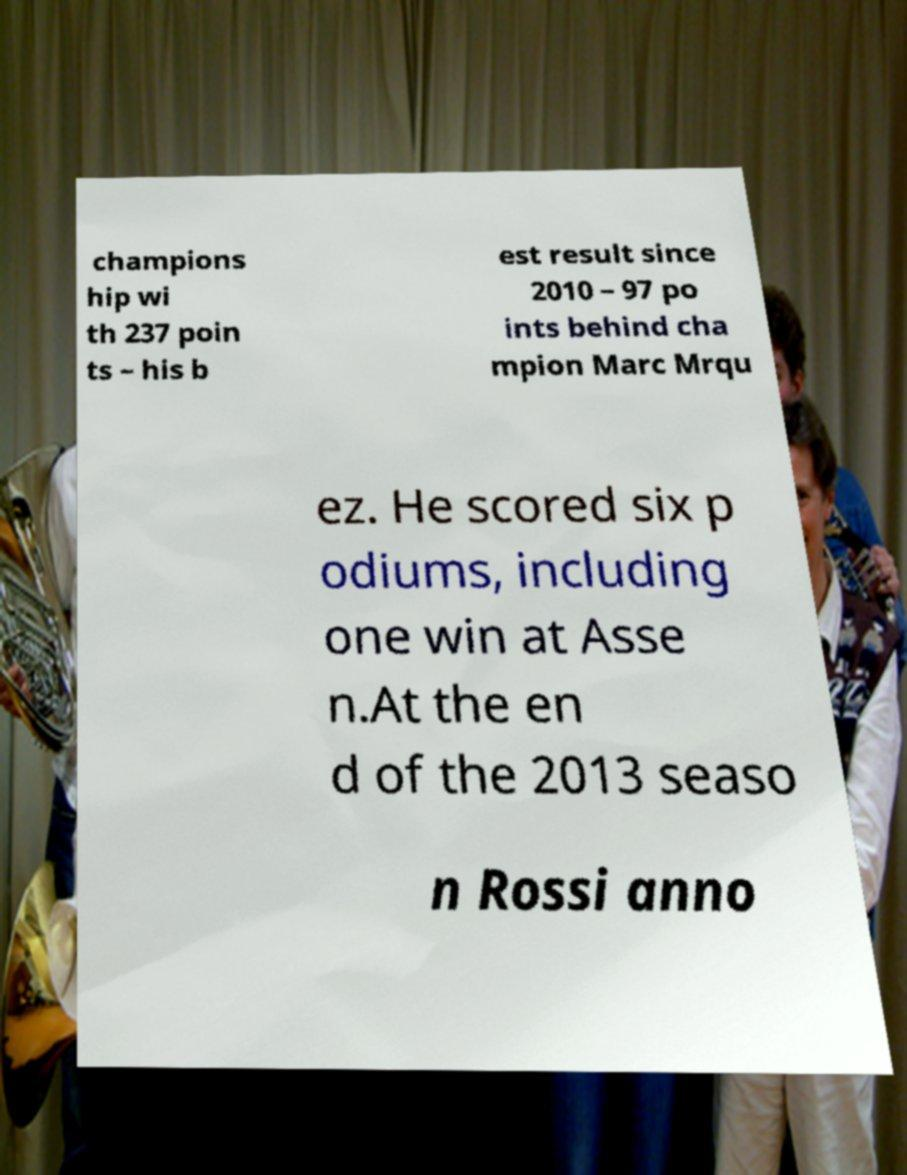There's text embedded in this image that I need extracted. Can you transcribe it verbatim? champions hip wi th 237 poin ts – his b est result since 2010 – 97 po ints behind cha mpion Marc Mrqu ez. He scored six p odiums, including one win at Asse n.At the en d of the 2013 seaso n Rossi anno 